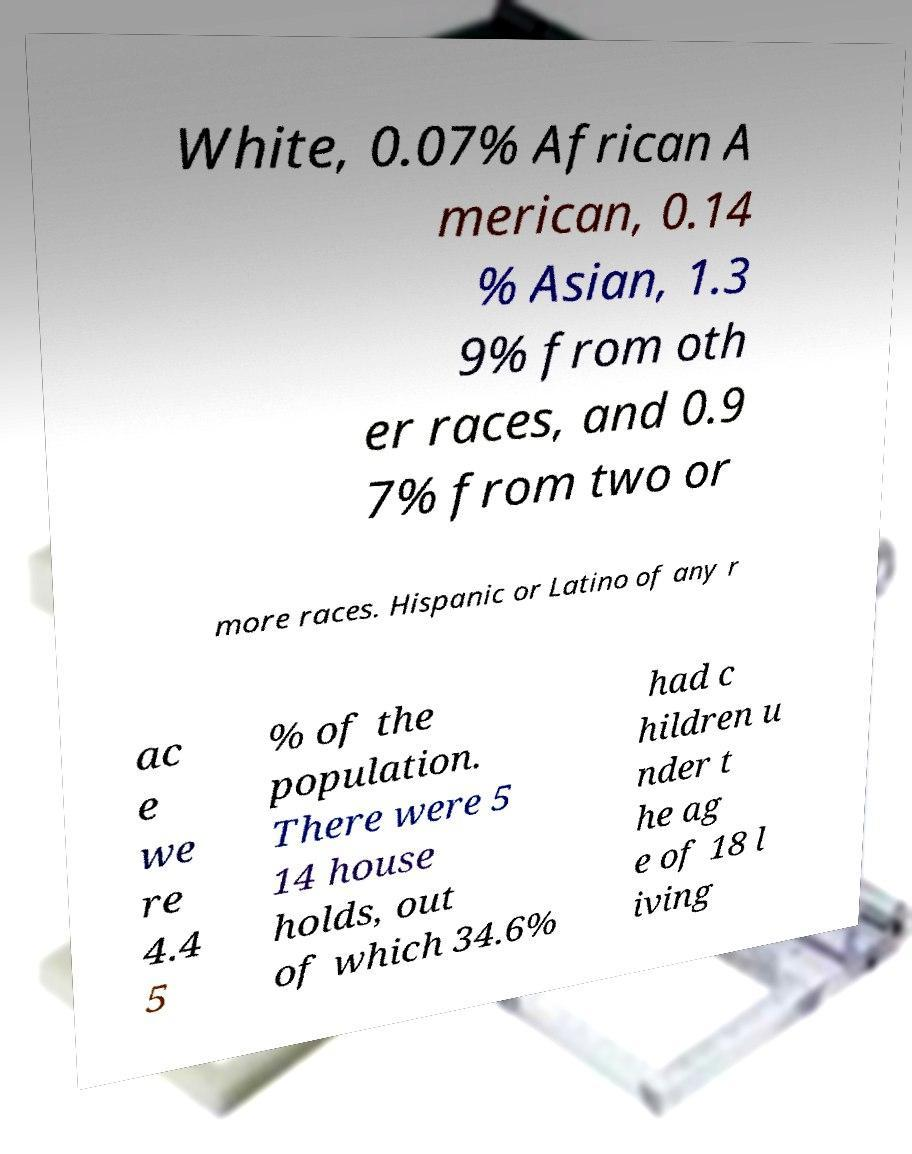Could you extract and type out the text from this image? White, 0.07% African A merican, 0.14 % Asian, 1.3 9% from oth er races, and 0.9 7% from two or more races. Hispanic or Latino of any r ac e we re 4.4 5 % of the population. There were 5 14 house holds, out of which 34.6% had c hildren u nder t he ag e of 18 l iving 